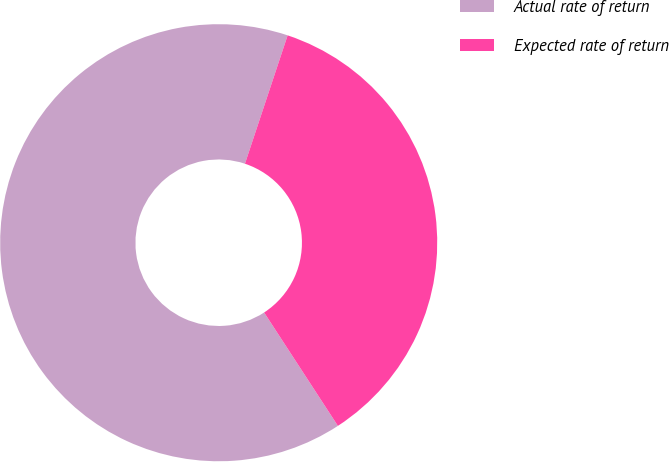Convert chart. <chart><loc_0><loc_0><loc_500><loc_500><pie_chart><fcel>Actual rate of return<fcel>Expected rate of return<nl><fcel>64.29%<fcel>35.71%<nl></chart> 